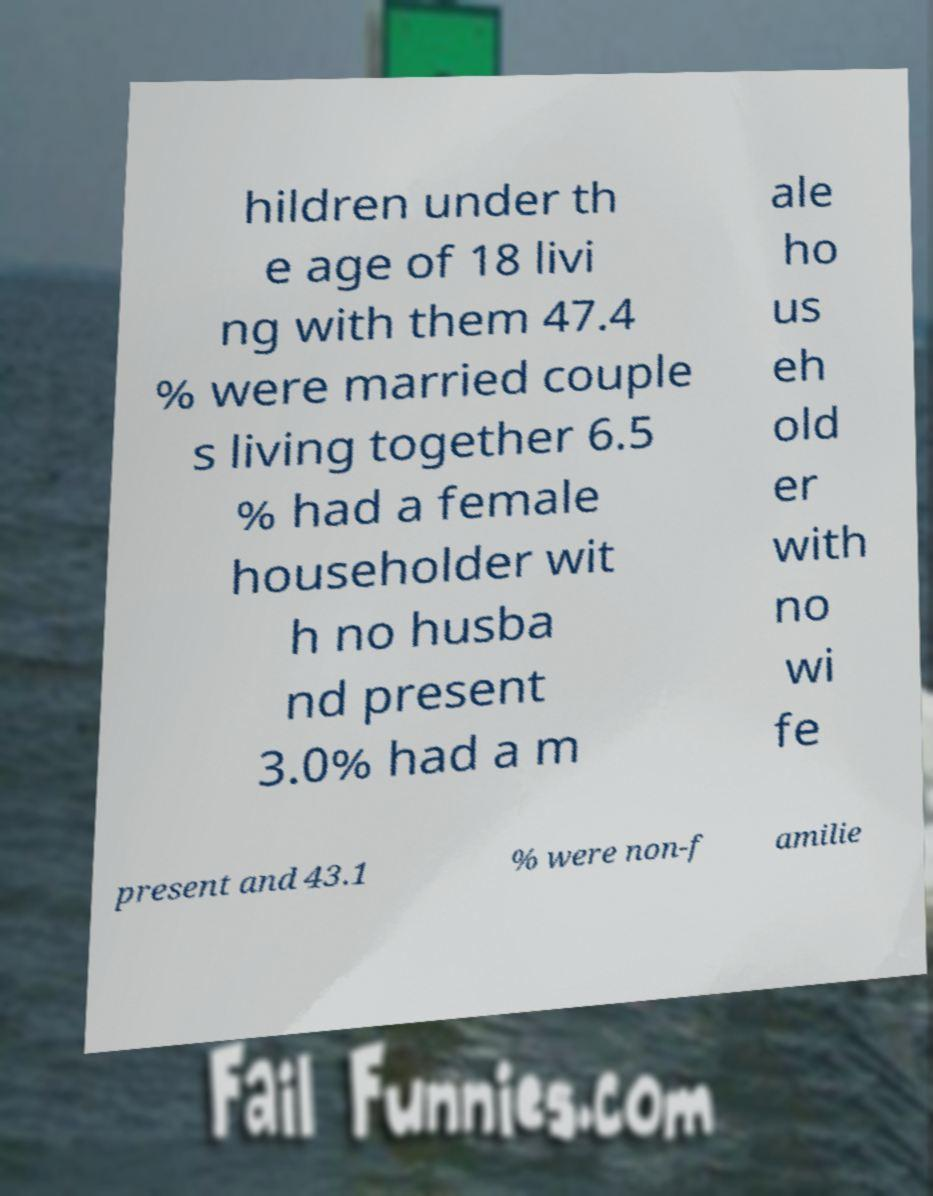For documentation purposes, I need the text within this image transcribed. Could you provide that? hildren under th e age of 18 livi ng with them 47.4 % were married couple s living together 6.5 % had a female householder wit h no husba nd present 3.0% had a m ale ho us eh old er with no wi fe present and 43.1 % were non-f amilie 